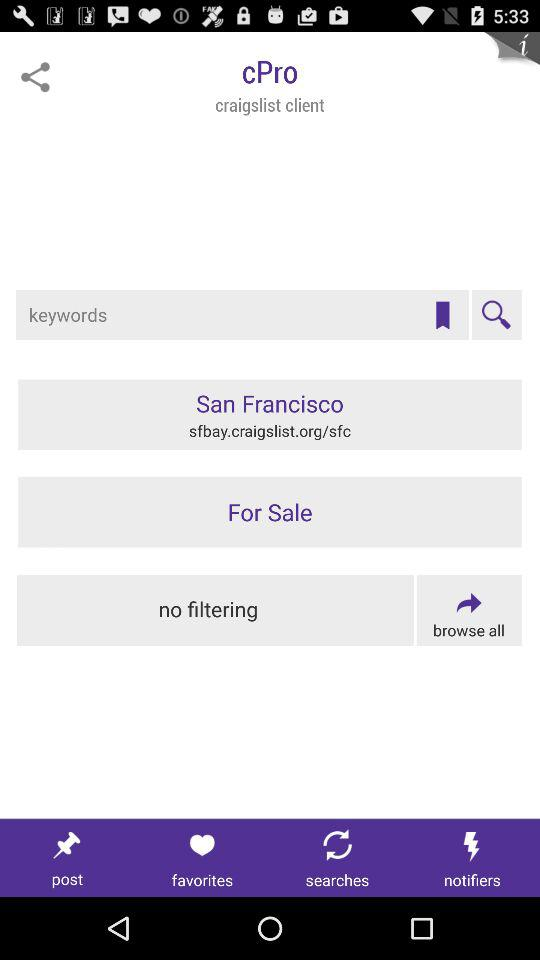What is the application name? The application name is "cPro". 